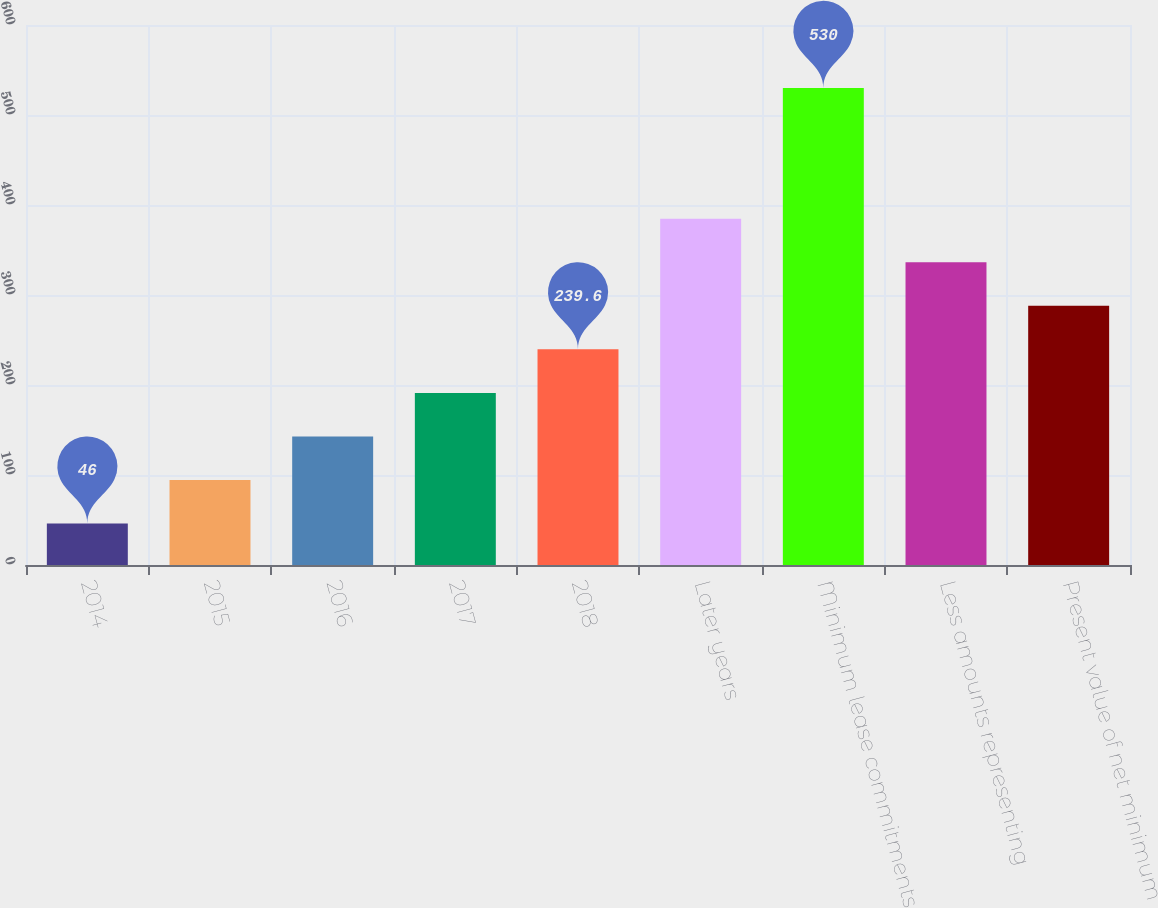Convert chart to OTSL. <chart><loc_0><loc_0><loc_500><loc_500><bar_chart><fcel>2014<fcel>2015<fcel>2016<fcel>2017<fcel>2018<fcel>Later years<fcel>Minimum lease commitments<fcel>Less amounts representing<fcel>Present value of net minimum<nl><fcel>46<fcel>94.4<fcel>142.8<fcel>191.2<fcel>239.6<fcel>384.8<fcel>530<fcel>336.4<fcel>288<nl></chart> 